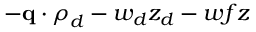<formula> <loc_0><loc_0><loc_500><loc_500>- q \cdot \rho _ { d } - w _ { d } z _ { d } - w f z</formula> 